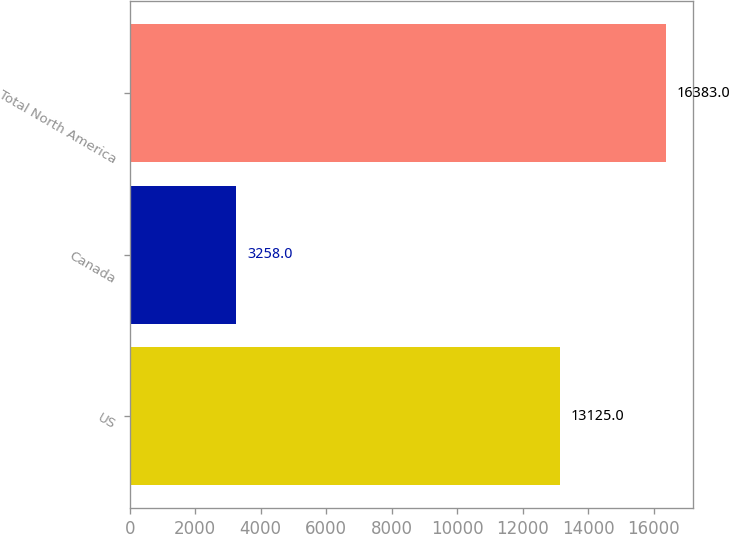<chart> <loc_0><loc_0><loc_500><loc_500><bar_chart><fcel>US<fcel>Canada<fcel>Total North America<nl><fcel>13125<fcel>3258<fcel>16383<nl></chart> 